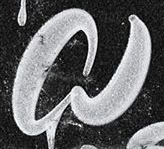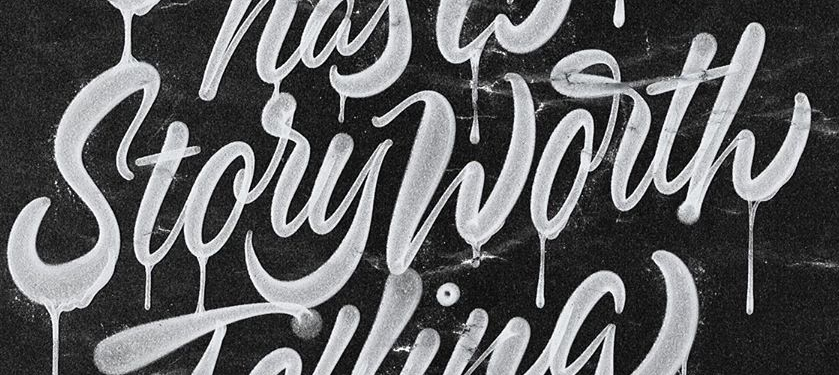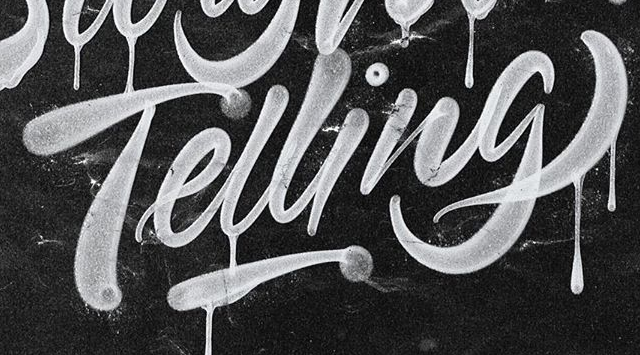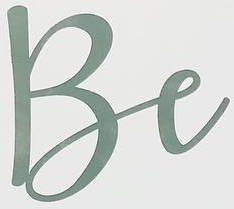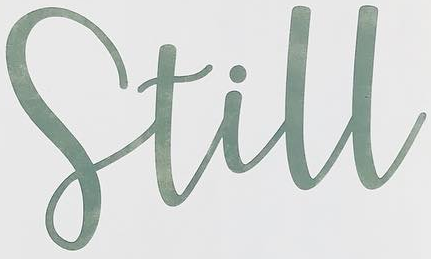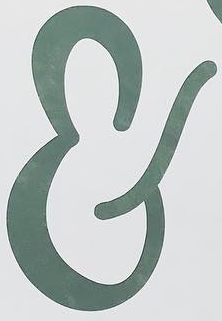What words can you see in these images in sequence, separated by a semicolon? a; StoryWorth; Telling; Be; Still; & 